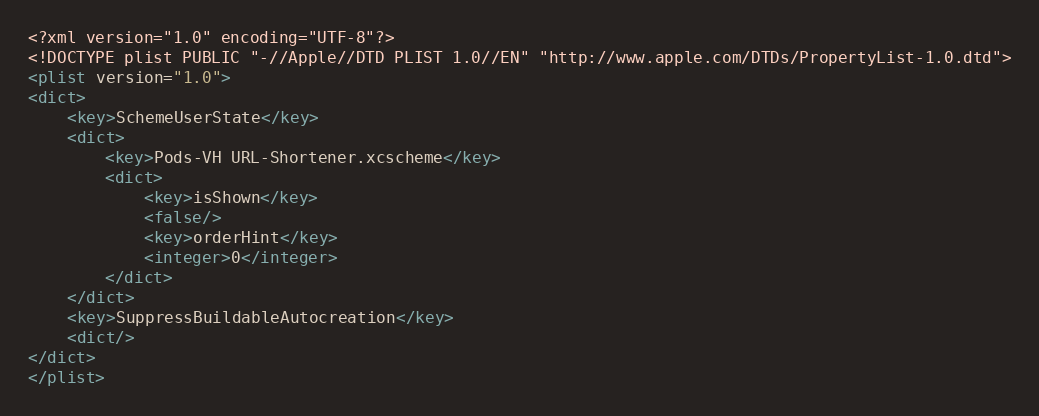Convert code to text. <code><loc_0><loc_0><loc_500><loc_500><_XML_><?xml version="1.0" encoding="UTF-8"?>
<!DOCTYPE plist PUBLIC "-//Apple//DTD PLIST 1.0//EN" "http://www.apple.com/DTDs/PropertyList-1.0.dtd">
<plist version="1.0">
<dict>
	<key>SchemeUserState</key>
	<dict>
		<key>Pods-VH URL-Shortener.xcscheme</key>
		<dict>
			<key>isShown</key>
			<false/>
			<key>orderHint</key>
			<integer>0</integer>
		</dict>
	</dict>
	<key>SuppressBuildableAutocreation</key>
	<dict/>
</dict>
</plist>
</code> 